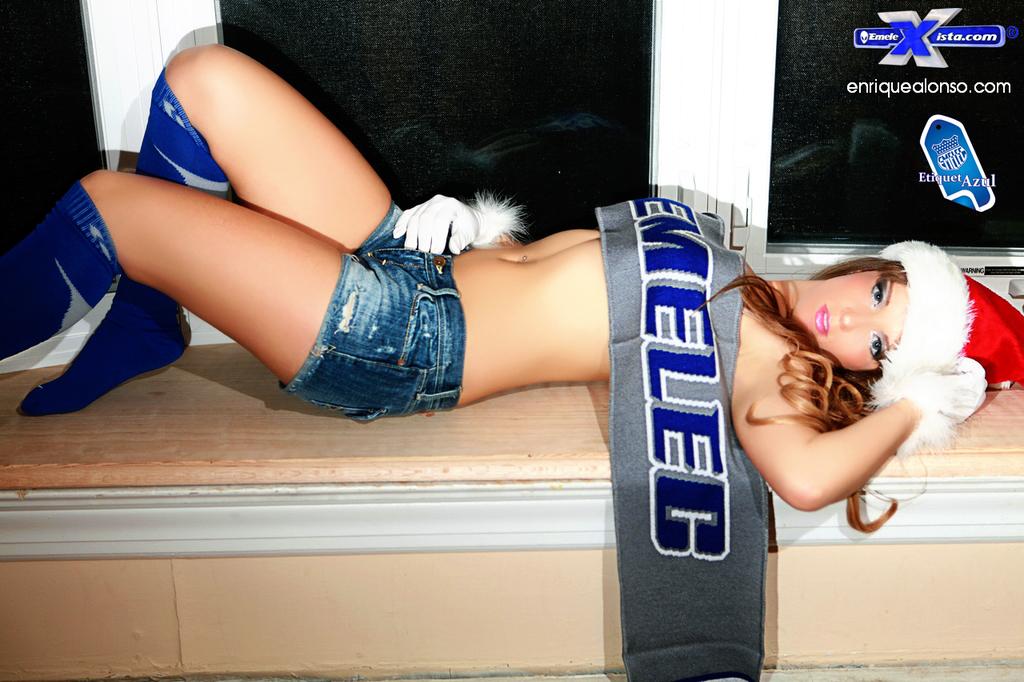What is this advertising?
Provide a short and direct response. Emelec. What website is on the picture?
Offer a very short reply. Enriquealonso.com. 